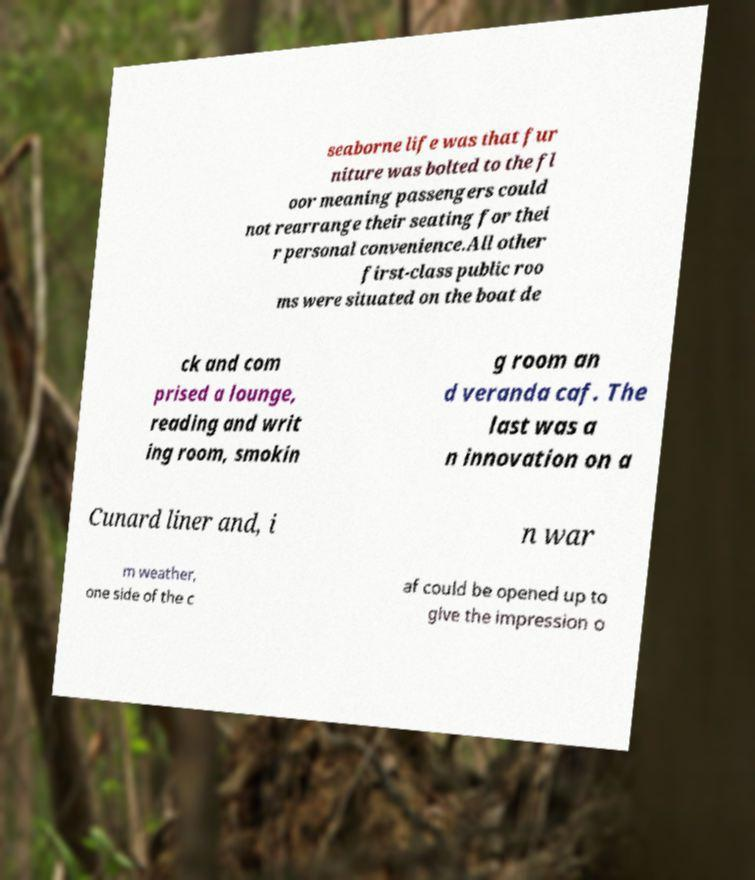What messages or text are displayed in this image? I need them in a readable, typed format. seaborne life was that fur niture was bolted to the fl oor meaning passengers could not rearrange their seating for thei r personal convenience.All other first-class public roo ms were situated on the boat de ck and com prised a lounge, reading and writ ing room, smokin g room an d veranda caf. The last was a n innovation on a Cunard liner and, i n war m weather, one side of the c af could be opened up to give the impression o 